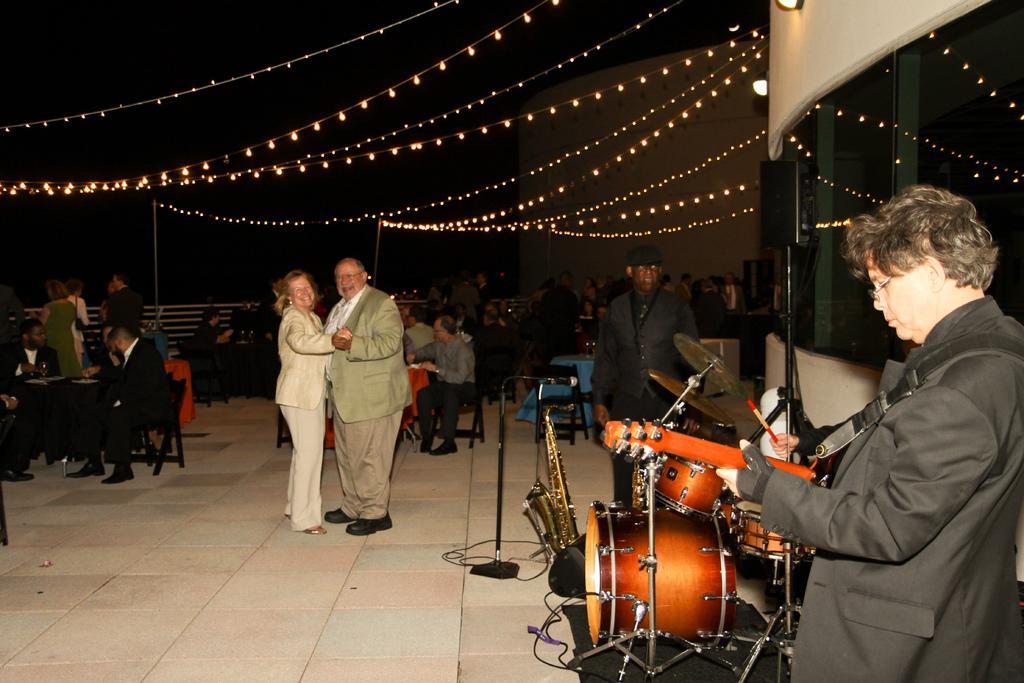Please provide a concise description of this image. This image consists of two persons dancing. They are wearing suits. On the right, there is a band setup. And a man wearing black suit is playing guitar. In the background, there are many people sitting in the chairs. At the bottom, there is a floor. At the top, we can see the rope lights. 